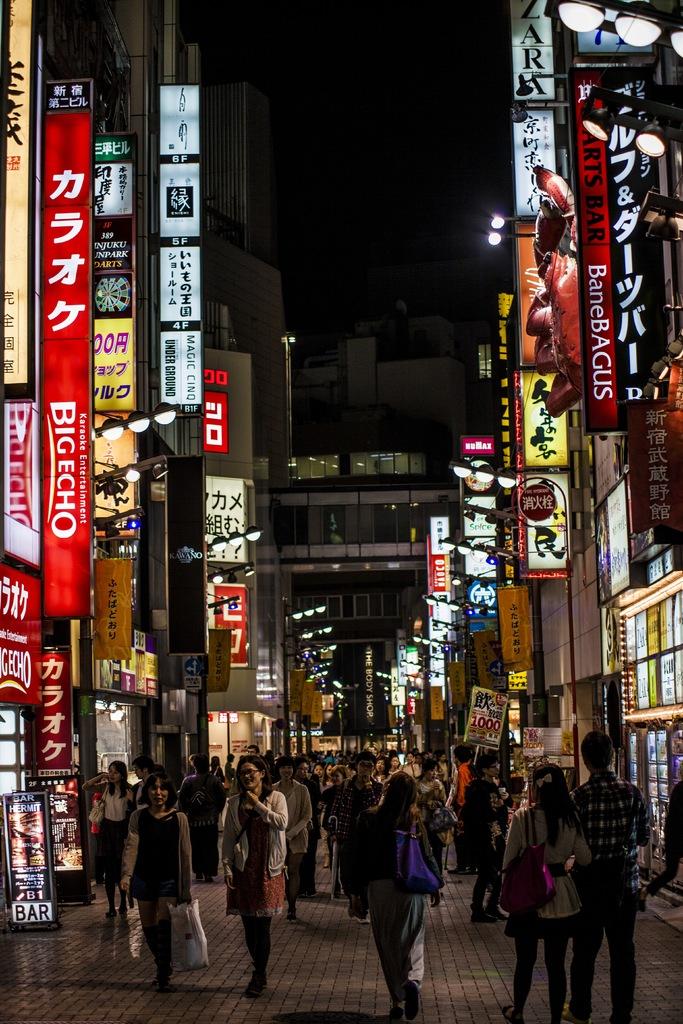What does the red sign on the right say?
Offer a very short reply. Banebagus. What size echo on the red dign?
Ensure brevity in your answer.  Big. 